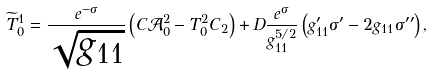Convert formula to latex. <formula><loc_0><loc_0><loc_500><loc_500>\widetilde { T } _ { 0 } ^ { 1 } = \frac { e ^ { - \sigma } } { \sqrt { g _ { 1 1 } } } \left ( C \mathcal { A } _ { 0 } ^ { 2 } - T _ { 0 } ^ { 2 } C _ { 2 } \right ) + D \frac { e ^ { \sigma } } { g _ { 1 1 } ^ { 5 / 2 } } \left ( g _ { 1 1 } ^ { \prime } \sigma ^ { \prime } - 2 g _ { 1 1 } \sigma ^ { \prime \prime } \right ) ,</formula> 